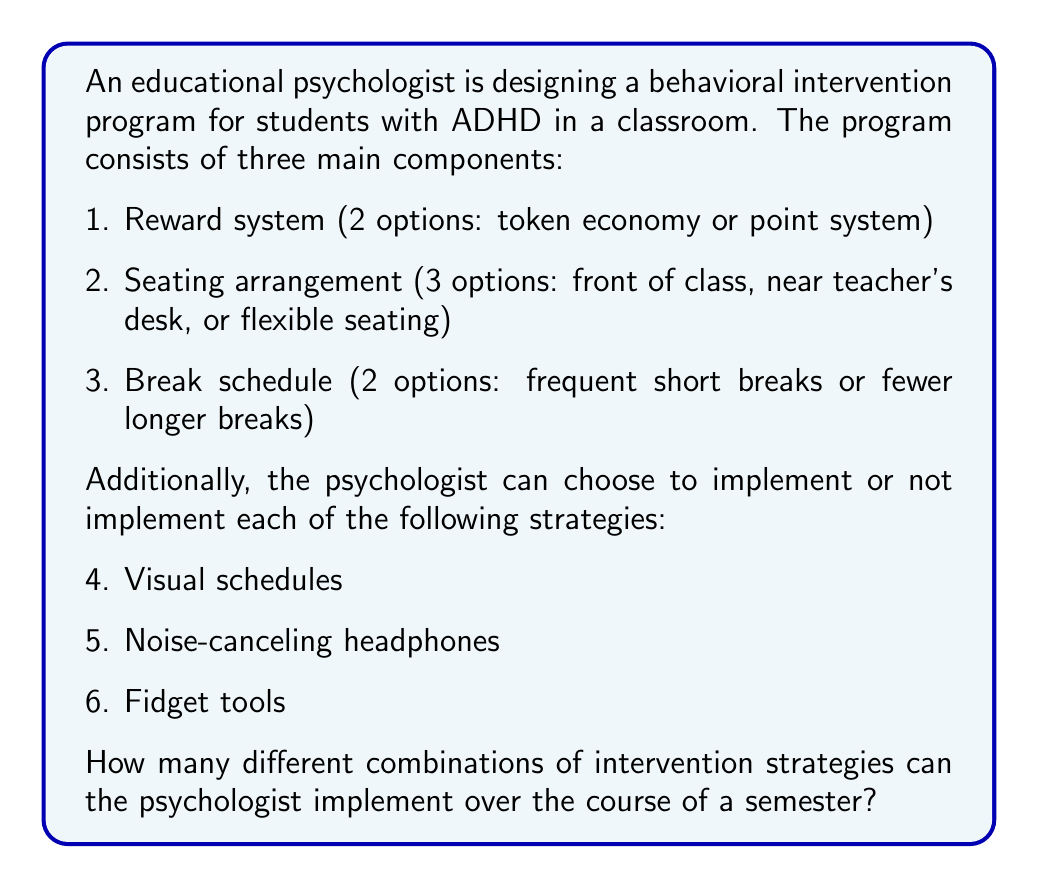Give your solution to this math problem. To solve this problem, we need to use the multiplication principle of counting. We'll break down the problem into its components and multiply the number of options for each:

1. Reward system: 2 options
2. Seating arrangement: 3 options
3. Break schedule: 2 options
4. Visual schedules: 2 options (implement or not)
5. Noise-canceling headphones: 2 options (implement or not)
6. Fidget tools: 2 options (implement or not)

The total number of possible combinations is the product of the number of options for each component:

$$2 \times 3 \times 2 \times 2 \times 2 \times 2 = 96$$

We can also express this as:

$$2^5 \times 3 = 96$$

This calculation accounts for all possible combinations of the intervention strategies, including implementing all, some, or none of the additional strategies (visual schedules, noise-canceling headphones, and fidget tools).
Answer: 96 different combinations 